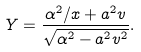Convert formula to latex. <formula><loc_0><loc_0><loc_500><loc_500>Y = \frac { \alpha ^ { 2 } / x + a ^ { 2 } v } { \sqrt { \alpha ^ { 2 } - a ^ { 2 } v ^ { 2 } } } .</formula> 